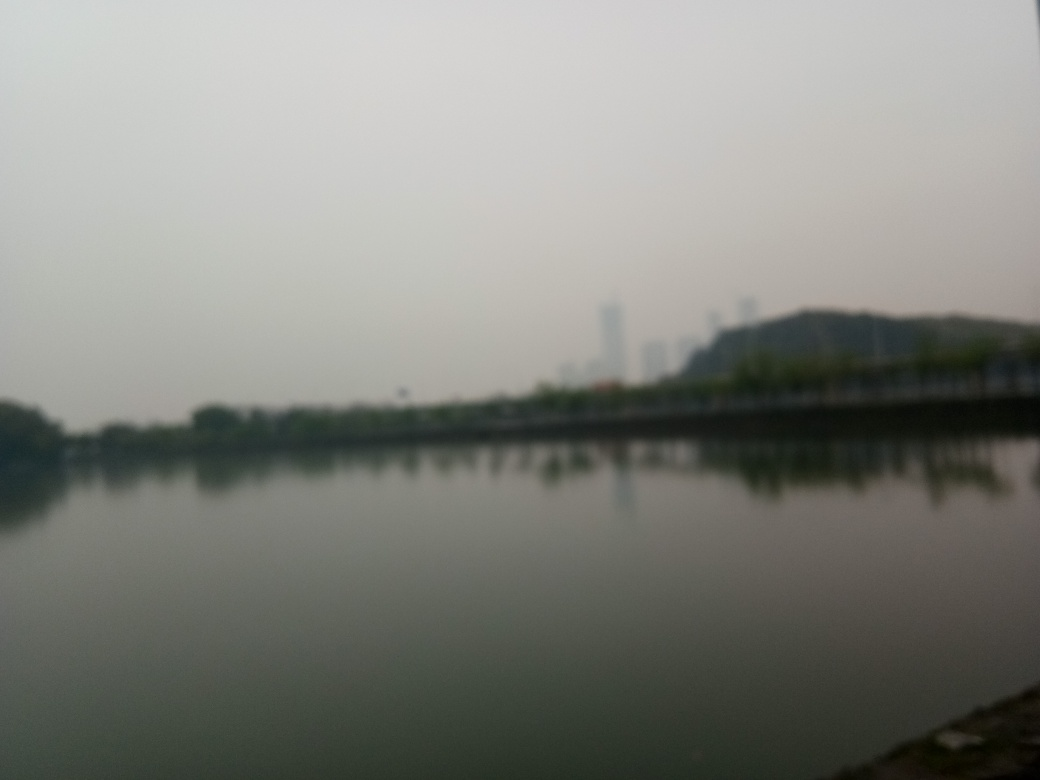Is there any human activity visible in this image? The image's resolution and exposure level make it challenging to discern details clearly. However, at first glance, there doesn't seem to be any immediate sign of human activity. Subjects such as people, vehicles, or boats are not readily apparent. 